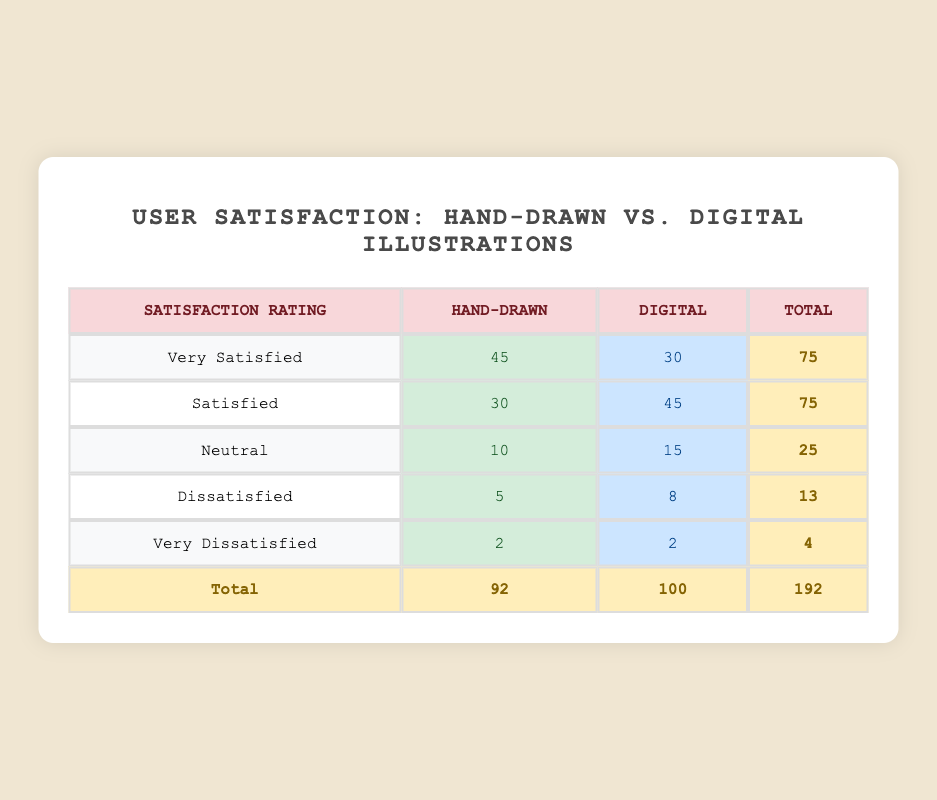What is the total user satisfaction rating for Hand-Drawn illustrations? The total user satisfaction rating for Hand-Drawn illustrations can be found by looking at the counts for each satisfaction rating in the Hand-Drawn column and adding them up: 45 + 30 + 10 + 5 + 2 = 92.
Answer: 92 What is the count of users who rated Digital illustrations as "Very Satisfied"? The count for users who rated Digital illustrations as "Very Satisfied" is directly provided in the table under the Digital column for that specific rating, which is 30.
Answer: 30 How many users rated both illustration types as "Very Dissatisfied"? By looking at both columns for the "Very Dissatisfied" rating, we see that both Hand-Drawn and Digital illustrations have a count of 2. Therefore, the total count of users who rated this as "Very Dissatisfied" is 2 (Hand-Drawn) + 2 (Digital) = 4.
Answer: 4 Which type of illustration received a higher number of "Satisfied" ratings? For "Satisfied" ratings, there are 30 for Hand-Drawn and 45 for Digital. Comparing the two, Digital has a higher count of 45 compared to Hand-Drawn's 30.
Answer: Digital What is the difference in the number of "Neutral" ratings between Hand-Drawn and Digital illustrations? To find this, we look at the "Neutral" row for both types. Hand-Drawn has 10 ratings while Digital has 15. The difference is calculated as 15 - 10 = 5.
Answer: 5 Are there more users who are "Dissatisfied" with Digital illustrations than with Hand-Drawn illustrations? Checking the counts, Hand-Drawn has 5 users who are "Dissatisfied", while Digital has 8 users. Since 8 is greater than 5, the answer is yes.
Answer: Yes What is the average satisfaction rating for Hand-Drawn illustrations? To calculate the average, we consider the values (Very Satisfied = 5, Satisfied = 4, Neutral = 3, Dissatisfied = 2, Very Dissatisfied = 1) and their frequencies: (45*5 + 30*4 + 10*3 + 5*2 + 2*1) / 92 = 4.16. The average satisfaction rating for Hand-Drawn illustrations is approximately 4.16.
Answer: 4.16 What percentage of users were "Very Satisfied" with Digital illustrations? To calculate the percentage, we take the count of "Very Satisfied" for Digital (30), divide by the total for Digital (100), and then multiply by 100: (30/100) * 100 = 30%.
Answer: 30% How many more users rated Hand-Drawn illustrations as "Very Satisfied" than as "Dissatisfied"? For Hand-Drawn illustrations, there are 45 users who are "Very Satisfied" and 5 who are "Dissatisfied". The difference is 45 - 5 = 40.
Answer: 40 